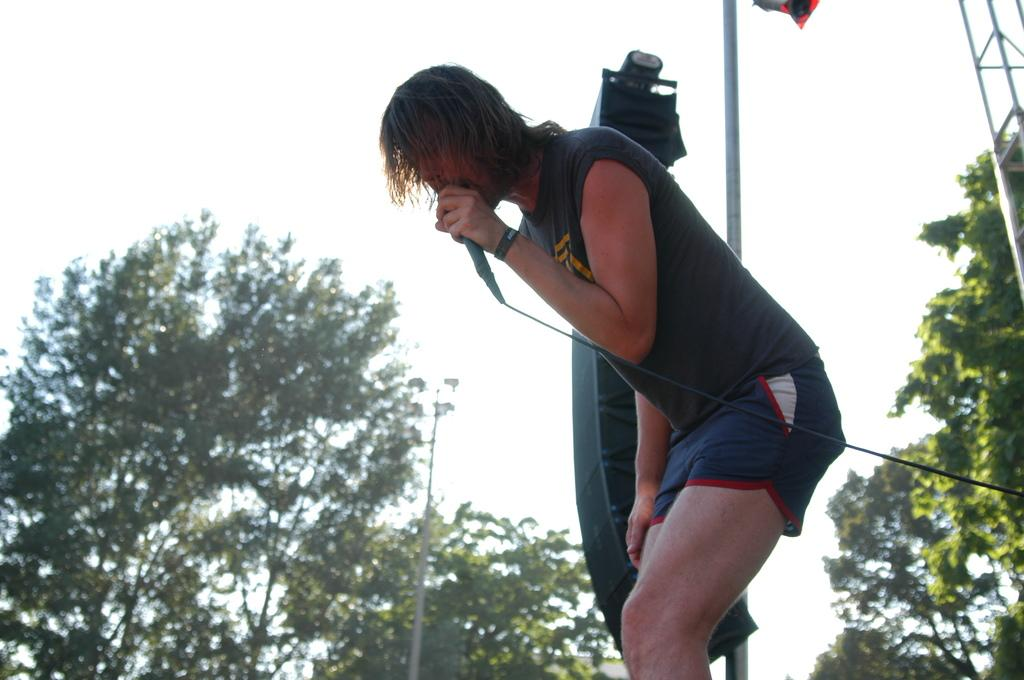Who or what is the main subject of the image? There is a person in the image. What is the person holding in the image? The person is holding a microphone. What is the person wearing in the image? The person is wearing a black t-shirt. What can be seen in the background of the image? The sky is visible at the top of the image, and there are trees in the image. What other object is present in the image? There is a pole in the image. How many grapes are hanging from the pole in the image? There are no grapes present in the image; the pole is not associated with any grapes. 